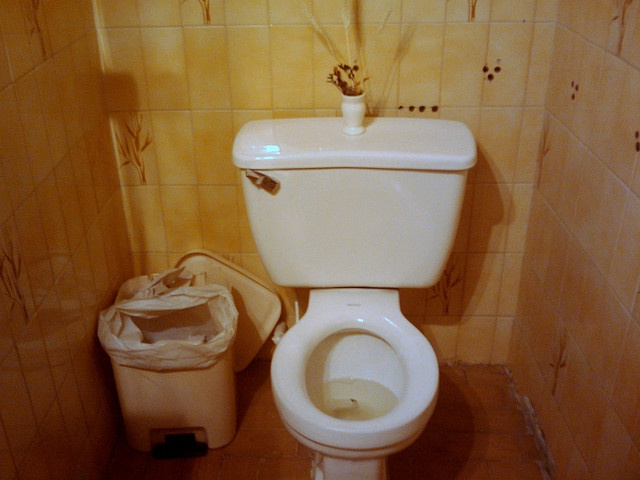Describe the objects in this image and their specific colors. I can see toilet in maroon, darkgray, and gray tones, potted plant in maroon, tan, darkgray, and olive tones, and vase in maroon, darkgray, tan, and lightgray tones in this image. 